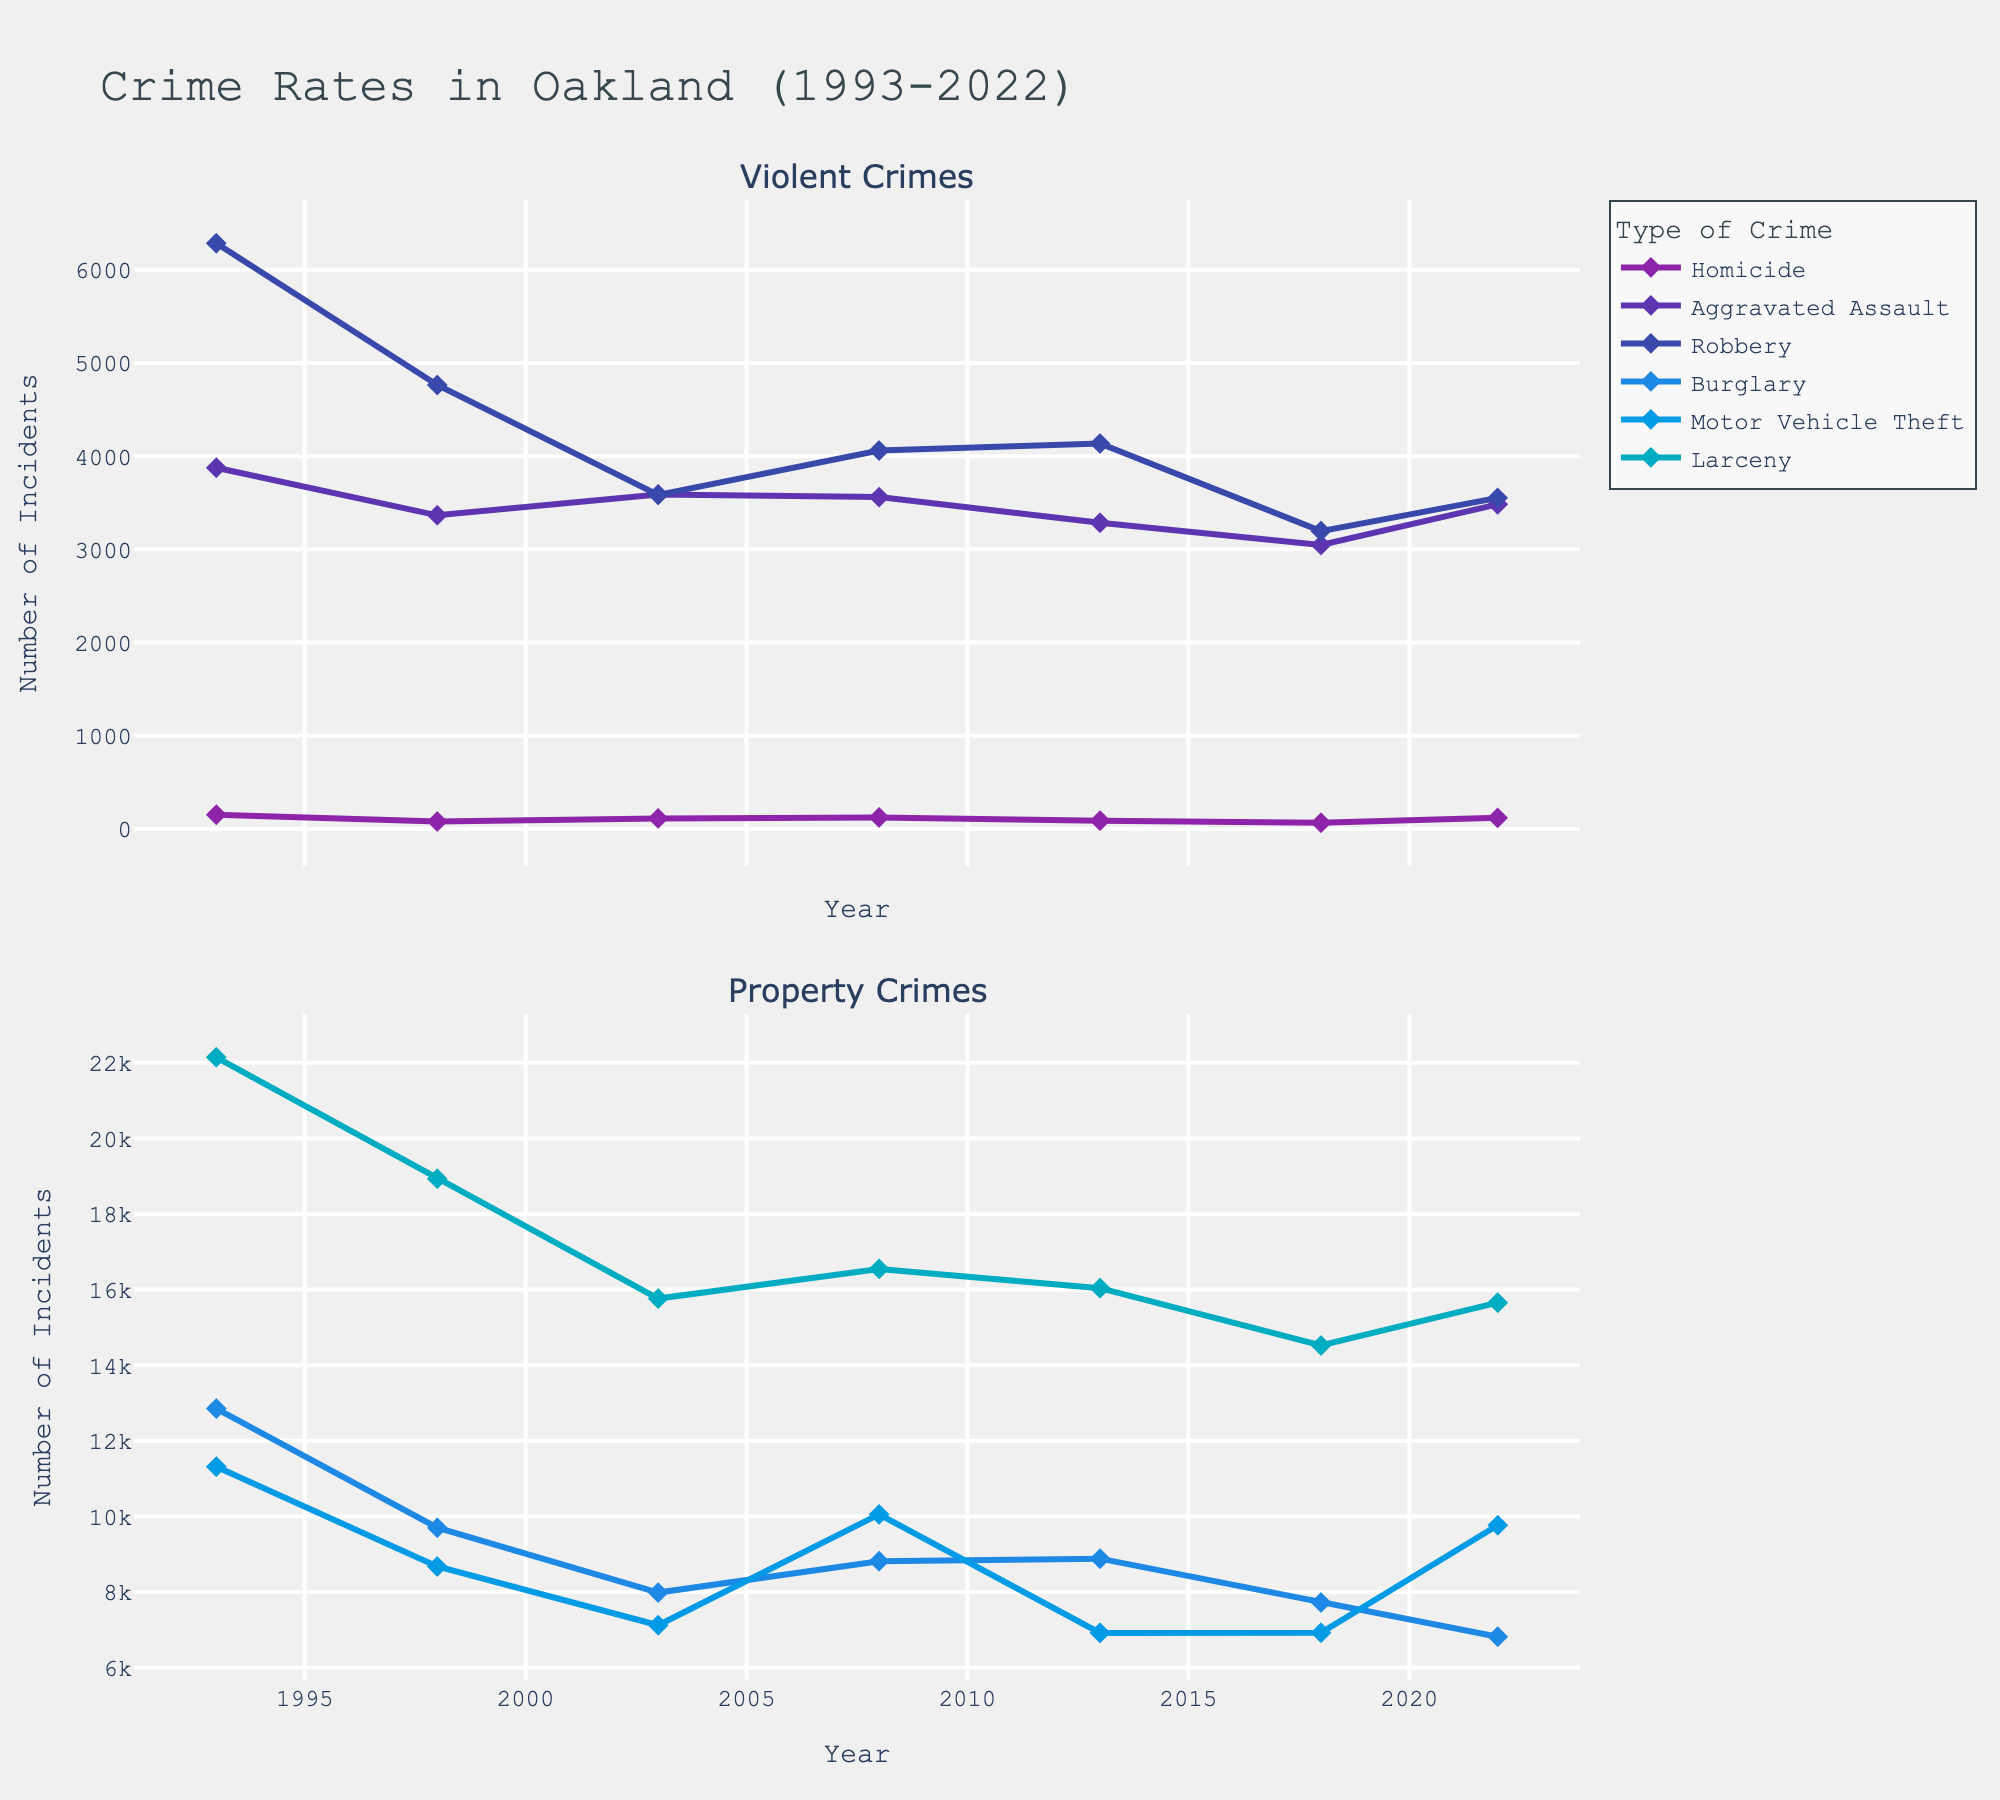What's the overall trend of homicide rates from 1993 to 2022? To determine the overall trend, we look at the homicide rates at the beginning and end points of the chart. Homicide rates start at 154 in 1993 and end at 120 in 2022, indicating a general downward trend with some fluctuations.
Answer: Downward Which category of crime experienced the largest drop in numbers between 1993 and 2022? To find the category with the largest drop, subtract the values for each crime in 2022 from their corresponding values in 1993. Comparisons show that Burglary dropped from 12853 to 6818, a reduction of 6035, which is the largest decline.
Answer: Burglary Between which two years did aggravated assaults see the smallest change in number? To identify this, examine the differences in aggravated assault numbers year by year. The smallest change is between 2018 and 2022, where the numbers went from 3047 to 3483, a change of 436.
Answer: 2018-2022 How does the number of motor vehicle thefts in 2022 compare to the number in 1998? Compare the motor vehicle theft numbers in 2022 (9767) and 1998 (8675). The number in 2022 is higher by 1092.
Answer: Higher What is the average number of robberies from 1993 to 2022? Sum the robbery numbers for all the years and then divide by the number of years: (6283+4764+3585+4060+4136+3196+3552)/7 equals 4225.14.
Answer: 4225.14 Which type of crime had the most stable trend over 30 years? Examine the plot lines for all crime types to see which one shows the least variability. The larceny trend appears the most stable with the least fluctuations.
Answer: Larceny In what year did aggravated assault numbers peak, and what was the value? Look through the aggravated assault trend line for the highest point, which is in 1993 with a value of 3876.
Answer: 1993, 3876 What was the percentage drop in burglaries from 1993 to 2022? Calculate the percentage drop using the formula [(initial value - final value) / initial value] * 100. For burglaries: [(12853 - 6818) / 12853] * 100 = 46.95%.
Answer: 46.95% Which crime type shows an increasing trend from 2018 to 2022? Check the lines between 2018 and 2022. Only motor vehicle theft shows an increasing trend from 6924 to 9767.
Answer: Motor Vehicle Theft How did the number of larceny crimes in 2003 compare to that in 2018? Compare the values for larceny in 2003 (15763) and 2018 (14521). The number decreased by 1242.
Answer: Decreased 